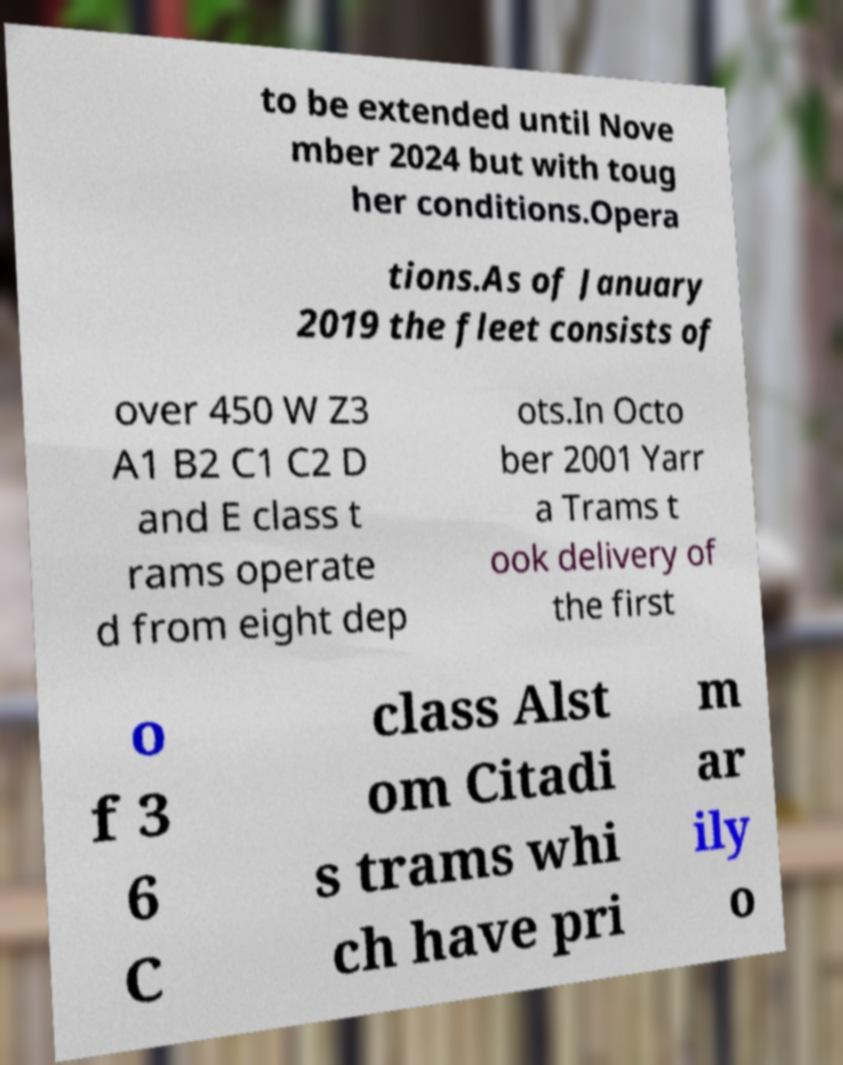There's text embedded in this image that I need extracted. Can you transcribe it verbatim? to be extended until Nove mber 2024 but with toug her conditions.Opera tions.As of January 2019 the fleet consists of over 450 W Z3 A1 B2 C1 C2 D and E class t rams operate d from eight dep ots.In Octo ber 2001 Yarr a Trams t ook delivery of the first o f 3 6 C class Alst om Citadi s trams whi ch have pri m ar ily o 